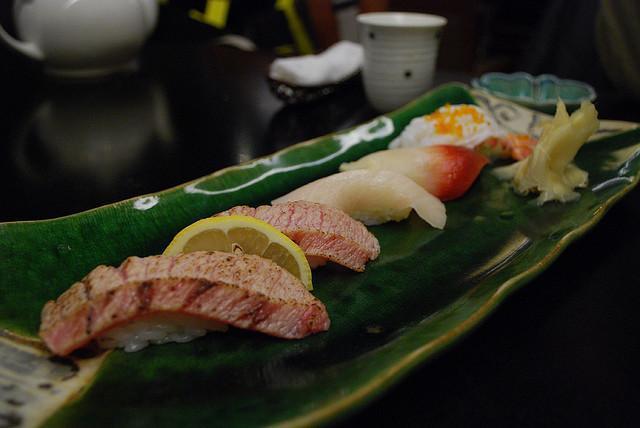Why would someone sit at this table?
Choose the right answer and clarify with the format: 'Answer: answer
Rationale: rationale.'
Options: To eat, to craft, to work, to sew. Answer: to eat.
Rationale: The person would want to eat the sushi. 